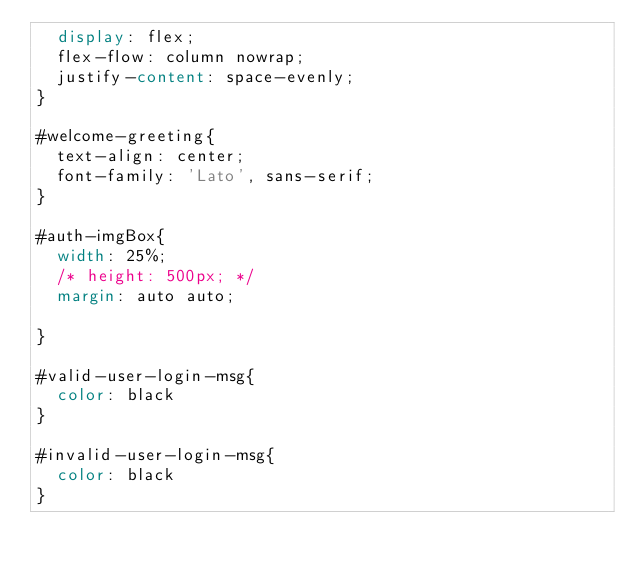<code> <loc_0><loc_0><loc_500><loc_500><_CSS_>  display: flex;
  flex-flow: column nowrap;
  justify-content: space-evenly;
}

#welcome-greeting{
  text-align: center;
  font-family: 'Lato', sans-serif;
}

#auth-imgBox{
  width: 25%;
  /* height: 500px; */
  margin: auto auto;

}

#valid-user-login-msg{
  color: black
}

#invalid-user-login-msg{
  color: black
}</code> 